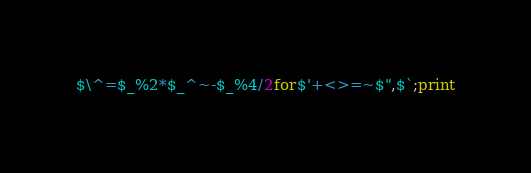Convert code to text. <code><loc_0><loc_0><loc_500><loc_500><_Perl_>$\^=$_%2*$_^~-$_%4/2for$'+<>=~$",$`;print</code> 